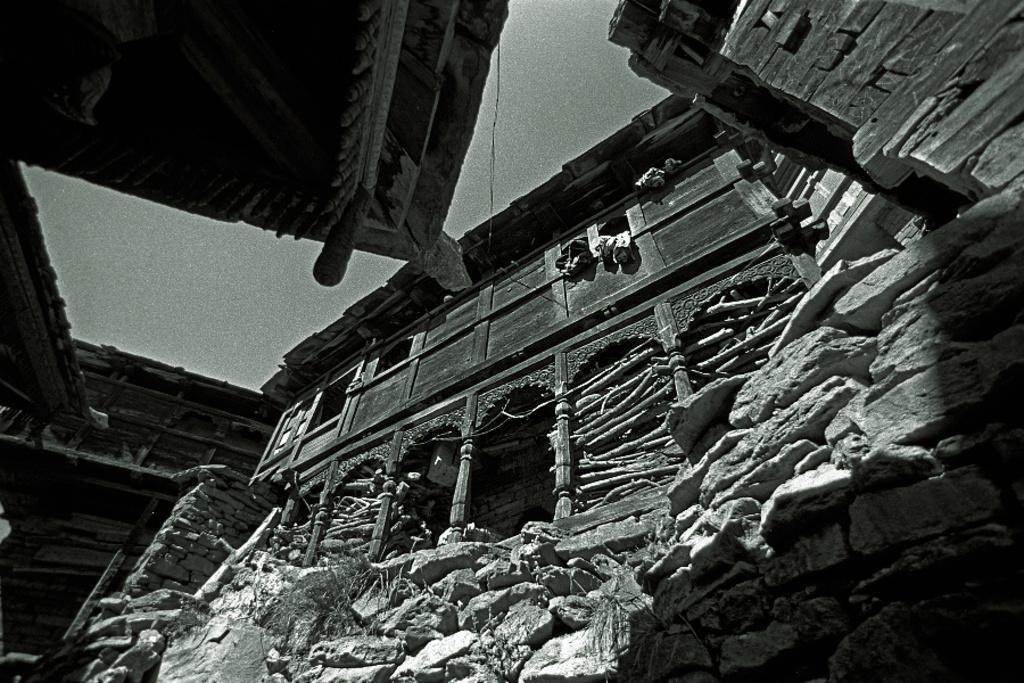How would you summarize this image in a sentence or two? In this image I can see buildings. On the right side there are stones. The picture is in black and white. 